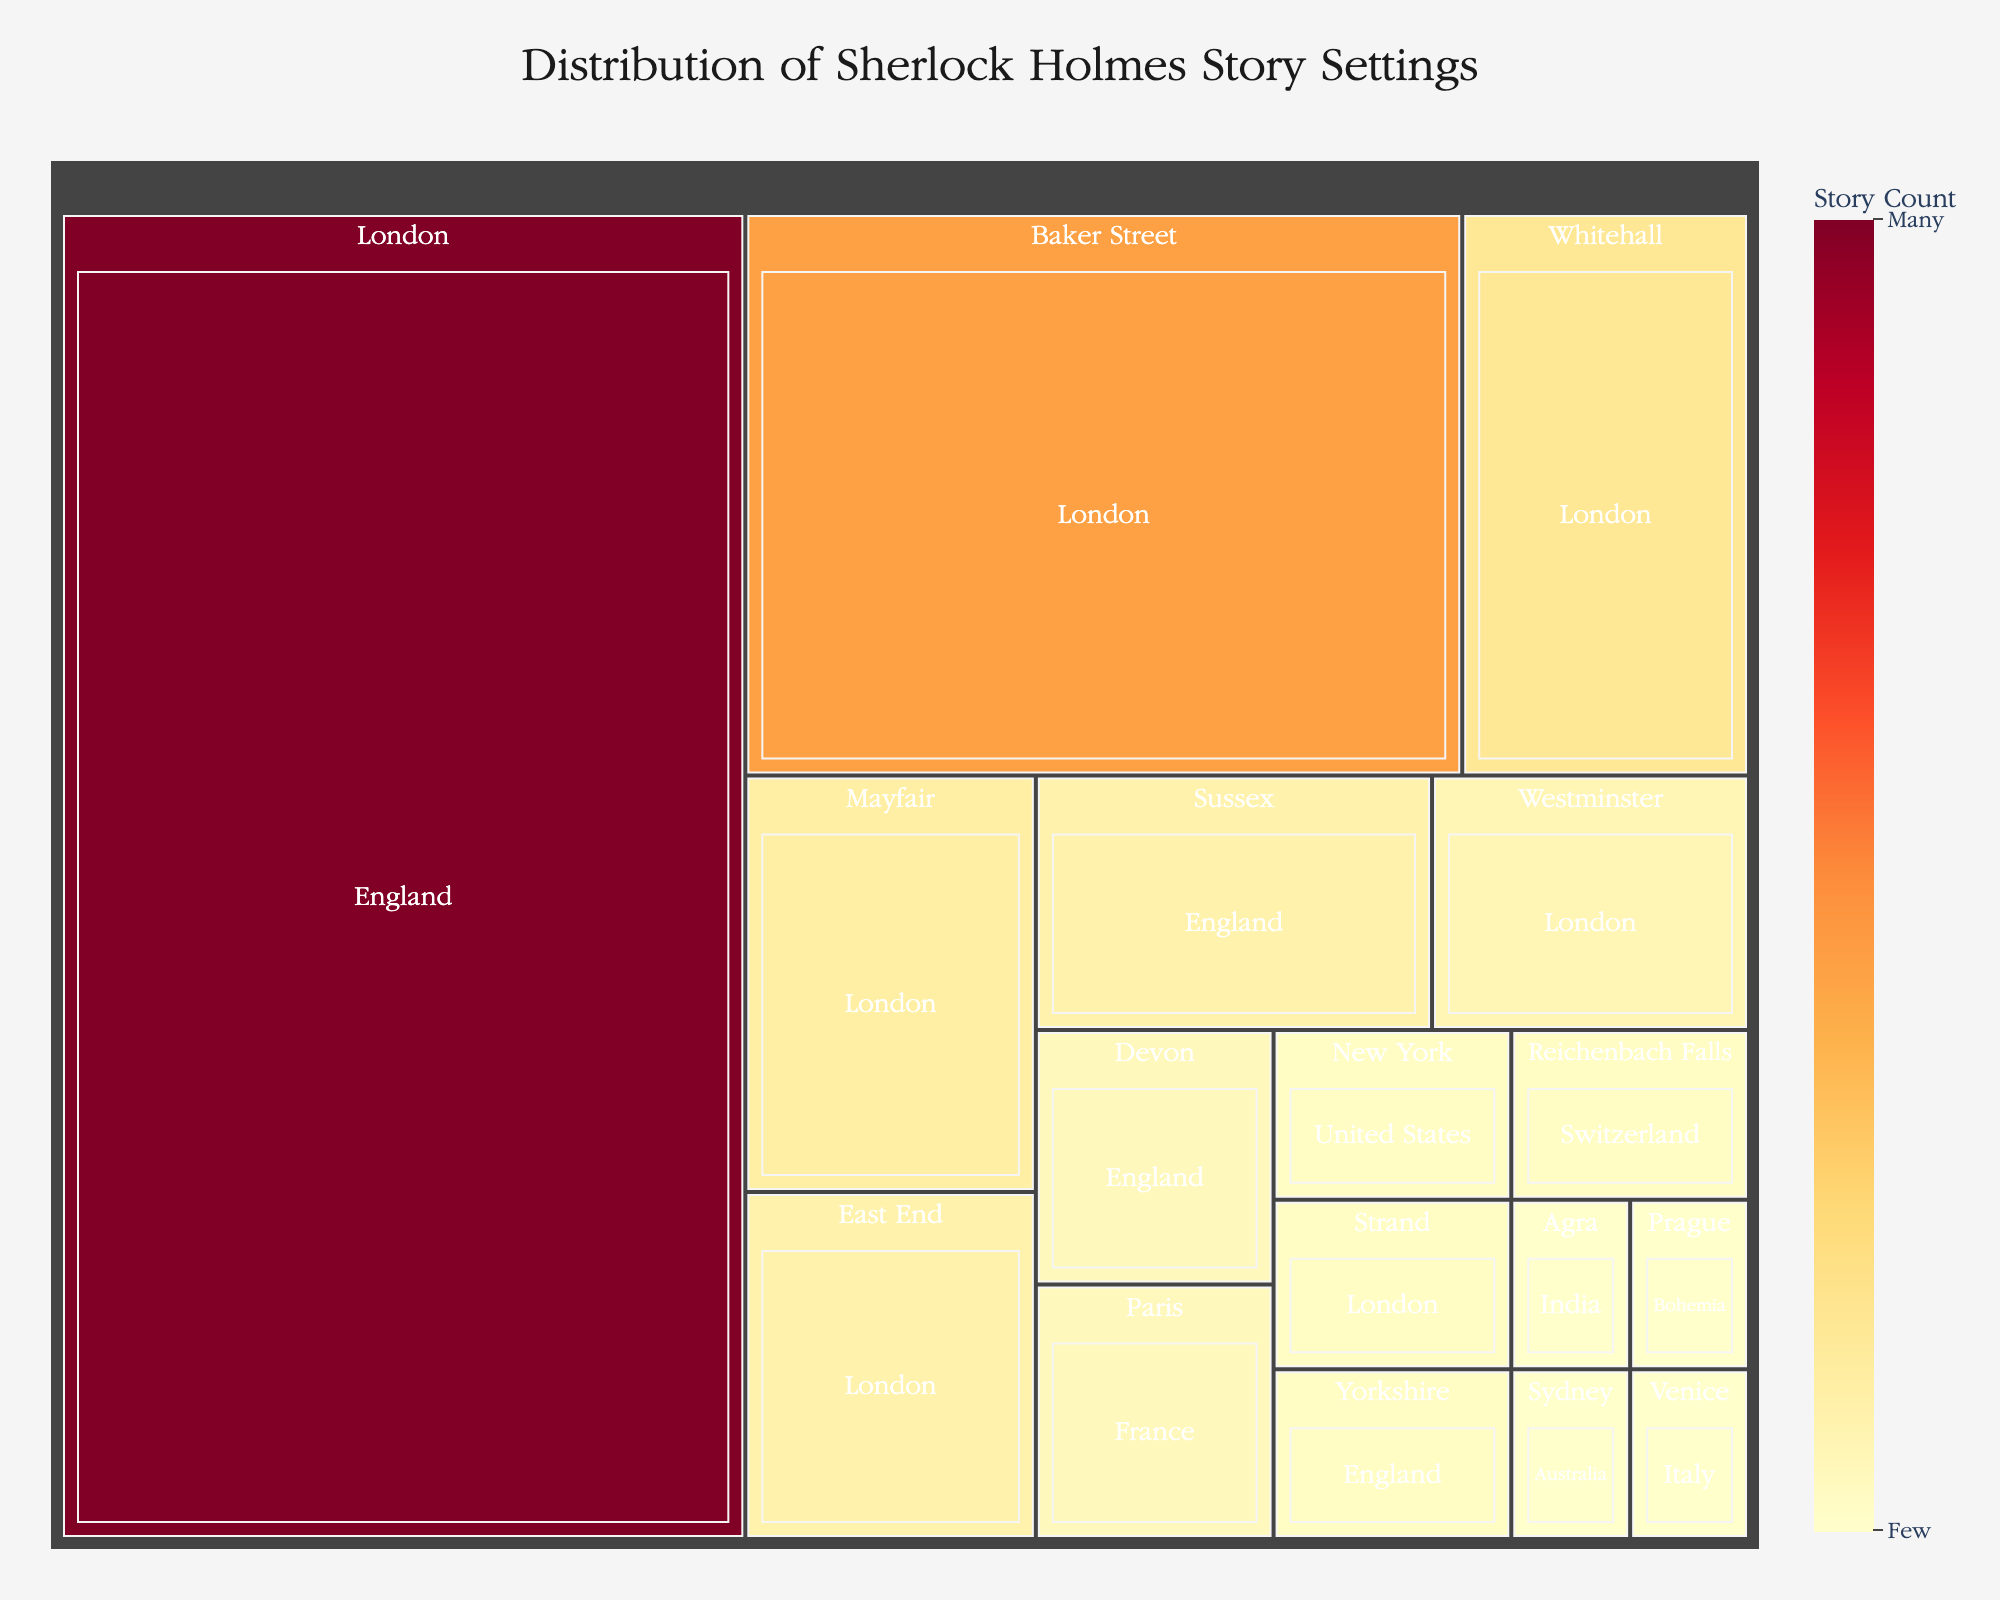What is the title of the Treemap figure? The title is located at the top of the figure and provides an overview of what the figure is about.
Answer: Distribution of Sherlock Holmes Story Settings Which location in London has the highest story count? By examining the areas within London, we can see that Baker Street has the largest segment, indicating the highest story count.
Answer: Baker Street How many stories are set in Yorkshire? Locate Yorkshire within the England region on the treemap and read the story count.
Answer: 2 Name two international locations featured in the plot with their story counts. On the treemap, international locations are those outside of the United Kingdom, such as Switzerland and France.
Answer: Reichenbach Falls (2), Paris (3) Which region has the most stories set overall? Look at the regions to see which has the highest combined story count. The 'England' section, especially within 'London,' has the majority.
Answer: London By how much does the story count in Baker Street exceed that of East End? Subtract the story count of East End from Baker Street. Baker Street has 20 and East End has 5.
Answer: 15 What color represents areas with the highest story count? Identify the color associated with the highest story count areas, noticing the color gradients used.
Answer: Dark Red Compare the combined story counts of Sussex and Devon. Which is higher and by how many? Add the story counts for Sussex (5) and Devon (3), then compare them and find the difference.
Answer: Sussex, by 2 What is the total number of story settings represented in the plot? Sum the story counts across all locations. This requires adding all counts: 45 (London) + 5 (Sussex) + 3 (Devon) + 2 (Yorkshire) + 20 (Baker Street) + 8 (Whitehall) + 6 (Mayfair) + 5 (East End) + 4 (Westminster) + 2 (Strand) + 2 (Reichenbach Falls) + 3 (Paris) + 2 (New York) + 1 (Venice) + 1 (Agra) + 1 (Prague) + 1 (Sydney).
Answer: 111 